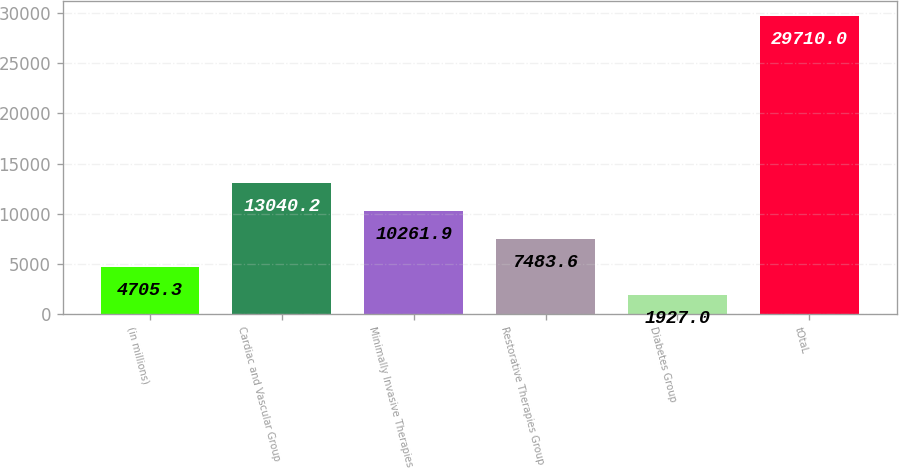Convert chart to OTSL. <chart><loc_0><loc_0><loc_500><loc_500><bar_chart><fcel>(in millions)<fcel>Cardiac and Vascular Group<fcel>Minimally Invasive Therapies<fcel>Restorative Therapies Group<fcel>Diabetes Group<fcel>tOtaL<nl><fcel>4705.3<fcel>13040.2<fcel>10261.9<fcel>7483.6<fcel>1927<fcel>29710<nl></chart> 